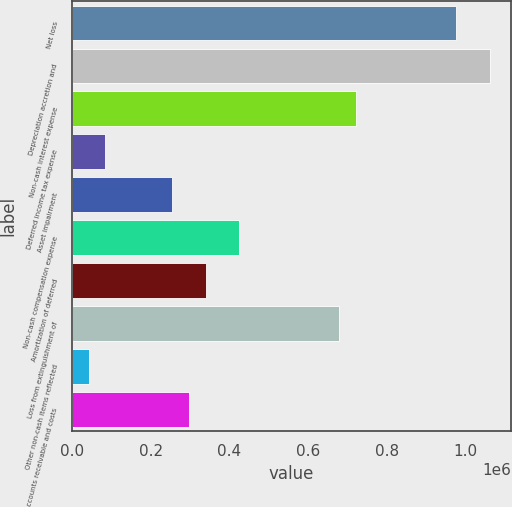<chart> <loc_0><loc_0><loc_500><loc_500><bar_chart><fcel>Net loss<fcel>Depreciation accretion and<fcel>Non-cash interest expense<fcel>Deferred income tax expense<fcel>Asset impairment<fcel>Non-cash compensation expense<fcel>Amortization of deferred<fcel>Loss from extinguishment of<fcel>Other non-cash items reflected<fcel>Accounts receivable and costs<nl><fcel>977570<fcel>1.06258e+06<fcel>722556<fcel>85019.8<fcel>255029<fcel>425039<fcel>340034<fcel>680053<fcel>42517.4<fcel>297532<nl></chart> 